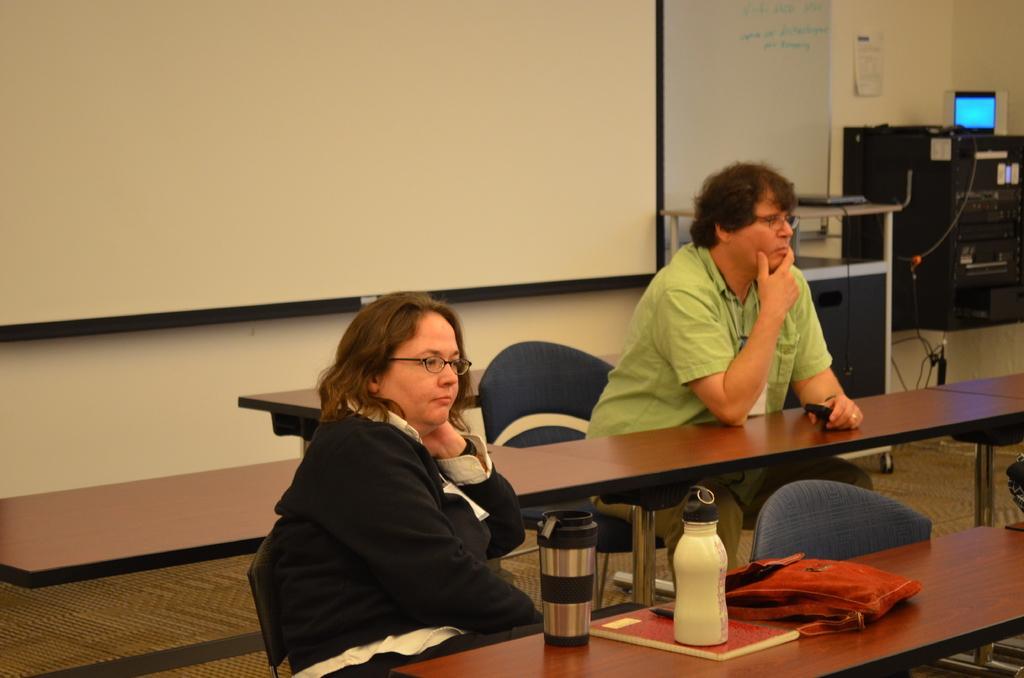How would you summarize this image in a sentence or two? On the background we can see a paper over a wall, white board. This is a floor. Here we can see persons sitting on chairs in front of a table and on the table we can see bottles, bag and a book. Here we can see a screen and a device. 